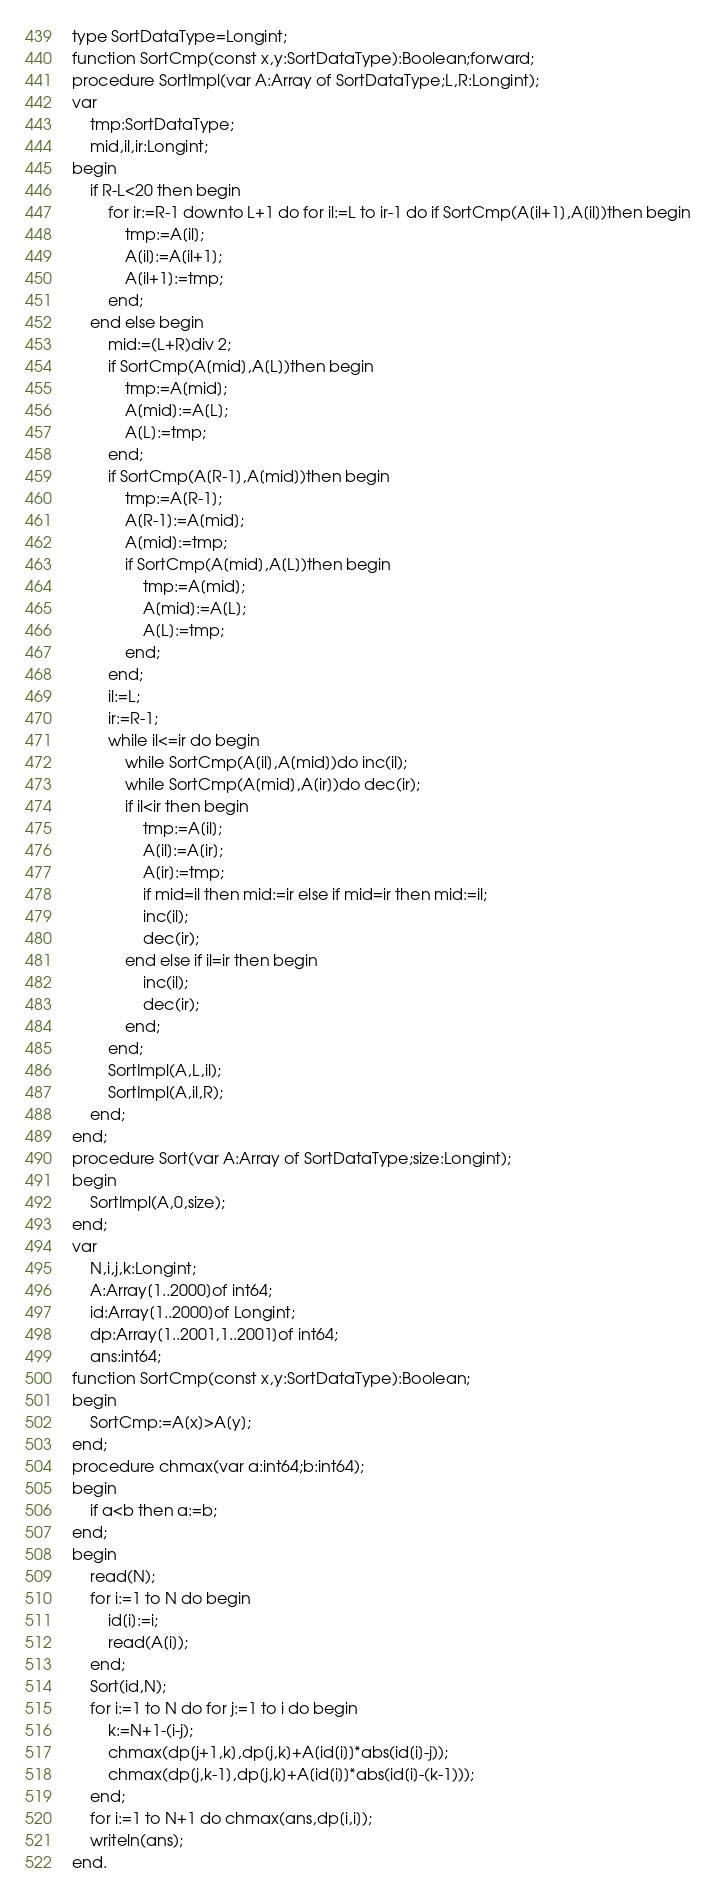Convert code to text. <code><loc_0><loc_0><loc_500><loc_500><_Pascal_>type SortDataType=Longint;
function SortCmp(const x,y:SortDataType):Boolean;forward;
procedure SortImpl(var A:Array of SortDataType;L,R:Longint);
var
	tmp:SortDataType;
	mid,il,ir:Longint;
begin
	if R-L<20 then begin
		for ir:=R-1 downto L+1 do for il:=L to ir-1 do if SortCmp(A[il+1],A[il])then begin
			tmp:=A[il];
			A[il]:=A[il+1];
			A[il+1]:=tmp;
		end;
	end else begin
		mid:=(L+R)div 2;
		if SortCmp(A[mid],A[L])then begin
			tmp:=A[mid];
			A[mid]:=A[L];
			A[L]:=tmp;
		end;
		if SortCmp(A[R-1],A[mid])then begin
			tmp:=A[R-1];
			A[R-1]:=A[mid];
			A[mid]:=tmp;
			if SortCmp(A[mid],A[L])then begin
				tmp:=A[mid];
				A[mid]:=A[L];
				A[L]:=tmp;
			end;
		end;
		il:=L;
		ir:=R-1;
		while il<=ir do begin
			while SortCmp(A[il],A[mid])do inc(il);
			while SortCmp(A[mid],A[ir])do dec(ir);
			if il<ir then begin
				tmp:=A[il];
				A[il]:=A[ir];
				A[ir]:=tmp;
				if mid=il then mid:=ir else if mid=ir then mid:=il;
				inc(il);
				dec(ir);
			end else if il=ir then begin
				inc(il);
				dec(ir);
			end;
		end;
		SortImpl(A,L,il);
		SortImpl(A,il,R);
	end;
end;
procedure Sort(var A:Array of SortDataType;size:Longint);
begin
	SortImpl(A,0,size);
end;
var
	N,i,j,k:Longint;
	A:Array[1..2000]of int64;
	id:Array[1..2000]of Longint;
	dp:Array[1..2001,1..2001]of int64;
	ans:int64;
function SortCmp(const x,y:SortDataType):Boolean;
begin
	SortCmp:=A[x]>A[y];
end;
procedure chmax(var a:int64;b:int64);
begin
	if a<b then a:=b;
end;
begin
	read(N);
	for i:=1 to N do begin
		id[i]:=i;
		read(A[i]);
	end;
	Sort(id,N);
	for i:=1 to N do for j:=1 to i do begin
		k:=N+1-(i-j);
		chmax(dp[j+1,k],dp[j,k]+A[id[i]]*abs(id[i]-j));
		chmax(dp[j,k-1],dp[j,k]+A[id[i]]*abs(id[i]-(k-1)));
	end;
	for i:=1 to N+1 do chmax(ans,dp[i,i]);
	writeln(ans);
end.
</code> 